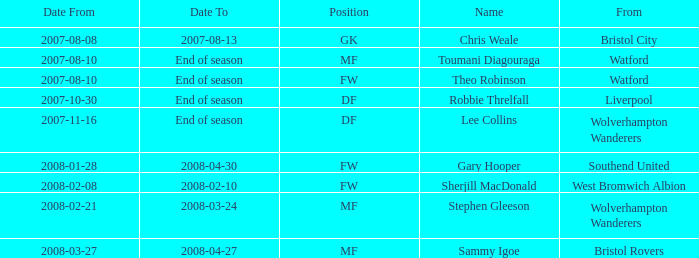Where was the player from who had the position of DF, who started 2007-10-30? Liverpool. Write the full table. {'header': ['Date From', 'Date To', 'Position', 'Name', 'From'], 'rows': [['2007-08-08', '2007-08-13', 'GK', 'Chris Weale', 'Bristol City'], ['2007-08-10', 'End of season', 'MF', 'Toumani Diagouraga', 'Watford'], ['2007-08-10', 'End of season', 'FW', 'Theo Robinson', 'Watford'], ['2007-10-30', 'End of season', 'DF', 'Robbie Threlfall', 'Liverpool'], ['2007-11-16', 'End of season', 'DF', 'Lee Collins', 'Wolverhampton Wanderers'], ['2008-01-28', '2008-04-30', 'FW', 'Gary Hooper', 'Southend United'], ['2008-02-08', '2008-02-10', 'FW', 'Sherjill MacDonald', 'West Bromwich Albion'], ['2008-02-21', '2008-03-24', 'MF', 'Stephen Gleeson', 'Wolverhampton Wanderers'], ['2008-03-27', '2008-04-27', 'MF', 'Sammy Igoe', 'Bristol Rovers']]} 